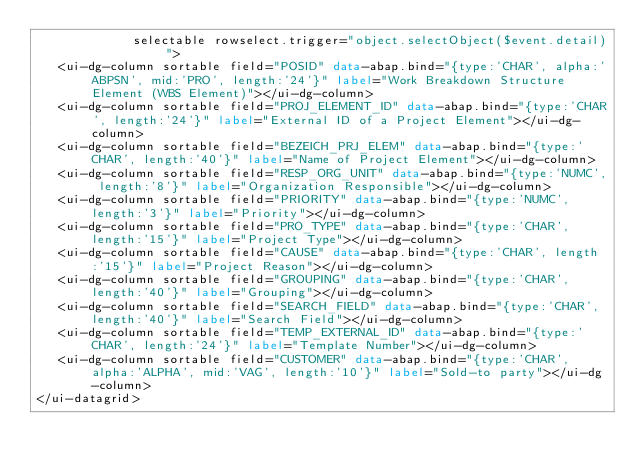<code> <loc_0><loc_0><loc_500><loc_500><_HTML_>             selectable rowselect.trigger="object.selectObject($event.detail)">
   <ui-dg-column sortable field="POSID" data-abap.bind="{type:'CHAR', alpha:'ABPSN', mid:'PRO', length:'24'}" label="Work Breakdown Structure Element (WBS Element)"></ui-dg-column>
   <ui-dg-column sortable field="PROJ_ELEMENT_ID" data-abap.bind="{type:'CHAR', length:'24'}" label="External ID of a Project Element"></ui-dg-column>
   <ui-dg-column sortable field="BEZEICH_PRJ_ELEM" data-abap.bind="{type:'CHAR', length:'40'}" label="Name of Project Element"></ui-dg-column>
   <ui-dg-column sortable field="RESP_ORG_UNIT" data-abap.bind="{type:'NUMC', length:'8'}" label="Organization Responsible"></ui-dg-column>
   <ui-dg-column sortable field="PRIORITY" data-abap.bind="{type:'NUMC', length:'3'}" label="Priority"></ui-dg-column>
   <ui-dg-column sortable field="PRO_TYPE" data-abap.bind="{type:'CHAR', length:'15'}" label="Project Type"></ui-dg-column>
   <ui-dg-column sortable field="CAUSE" data-abap.bind="{type:'CHAR', length:'15'}" label="Project Reason"></ui-dg-column>
   <ui-dg-column sortable field="GROUPING" data-abap.bind="{type:'CHAR', length:'40'}" label="Grouping"></ui-dg-column>
   <ui-dg-column sortable field="SEARCH_FIELD" data-abap.bind="{type:'CHAR', length:'40'}" label="Search Field"></ui-dg-column>
   <ui-dg-column sortable field="TEMP_EXTERNAL_ID" data-abap.bind="{type:'CHAR', length:'24'}" label="Template Number"></ui-dg-column>
   <ui-dg-column sortable field="CUSTOMER" data-abap.bind="{type:'CHAR', alpha:'ALPHA', mid:'VAG', length:'10'}" label="Sold-to party"></ui-dg-column>
</ui-datagrid></code> 